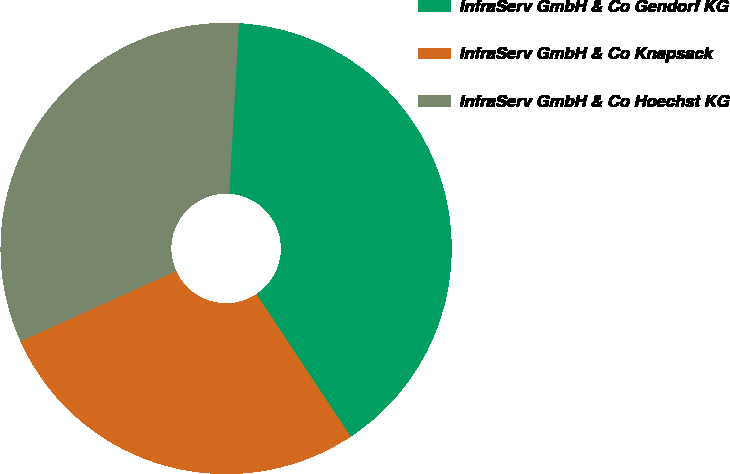Convert chart to OTSL. <chart><loc_0><loc_0><loc_500><loc_500><pie_chart><fcel>InfraServ GmbH & Co Gendorf KG<fcel>InfraServ GmbH & Co Knapsack<fcel>InfraServ GmbH & Co Hoechst KG<nl><fcel>39.8%<fcel>27.55%<fcel>32.65%<nl></chart> 